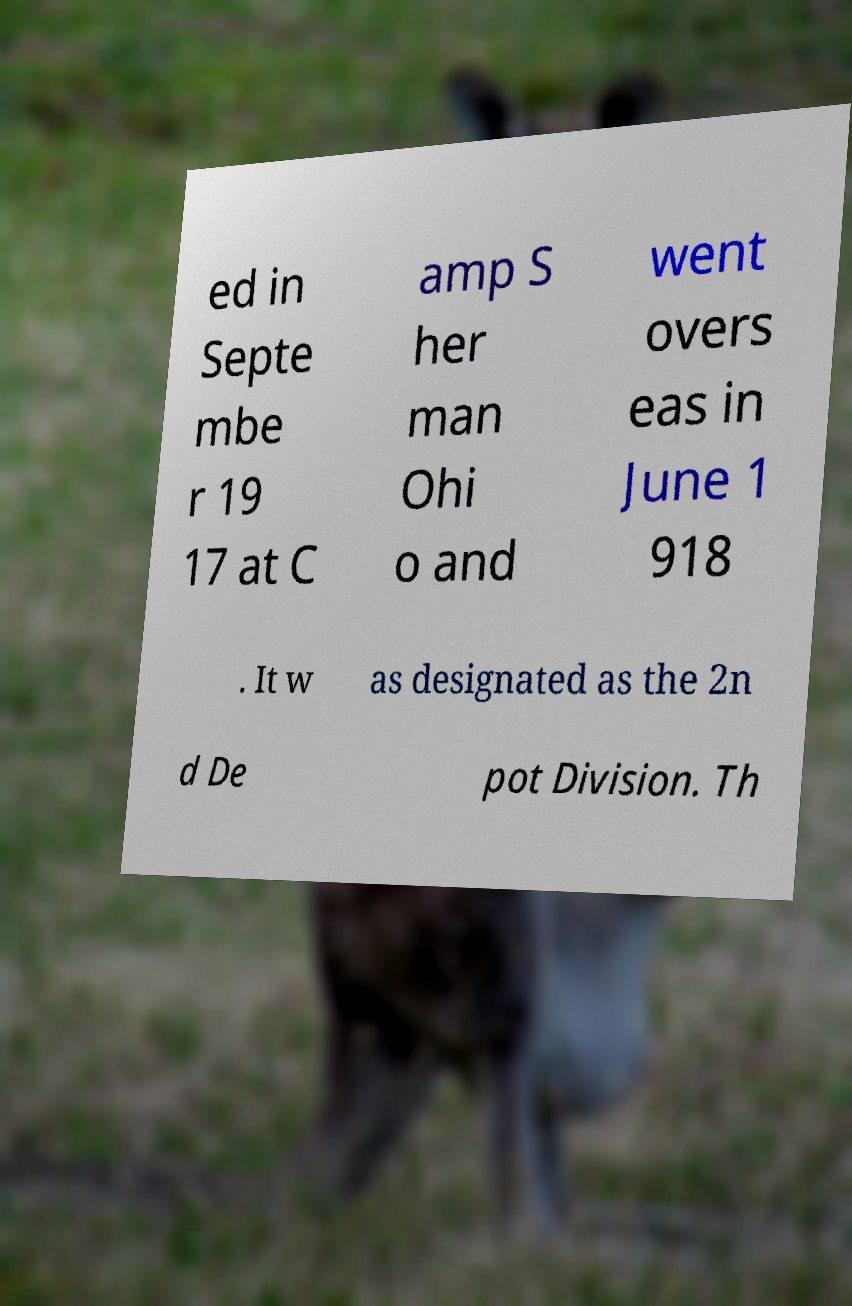Could you extract and type out the text from this image? ed in Septe mbe r 19 17 at C amp S her man Ohi o and went overs eas in June 1 918 . It w as designated as the 2n d De pot Division. Th 